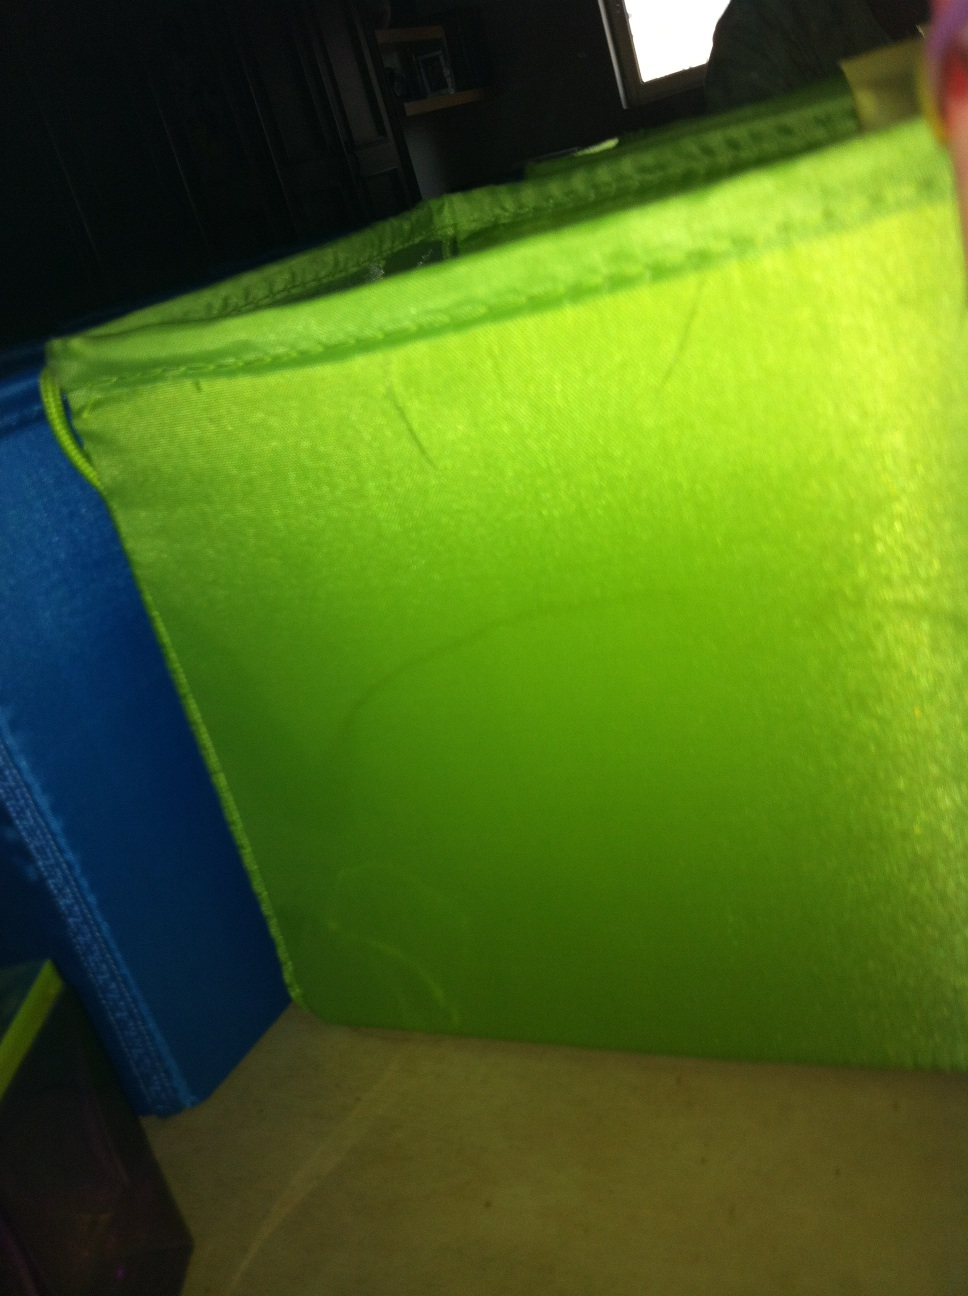Can you tell what the surrounding objects might be? While the image focuses primarily on the green container, we can see parts of what seem to be shelves or other furniture. The edges of a darker-colored object, possibly a couch or a wooden piece of furniture, are visible. The room suggests a home or office environment. 